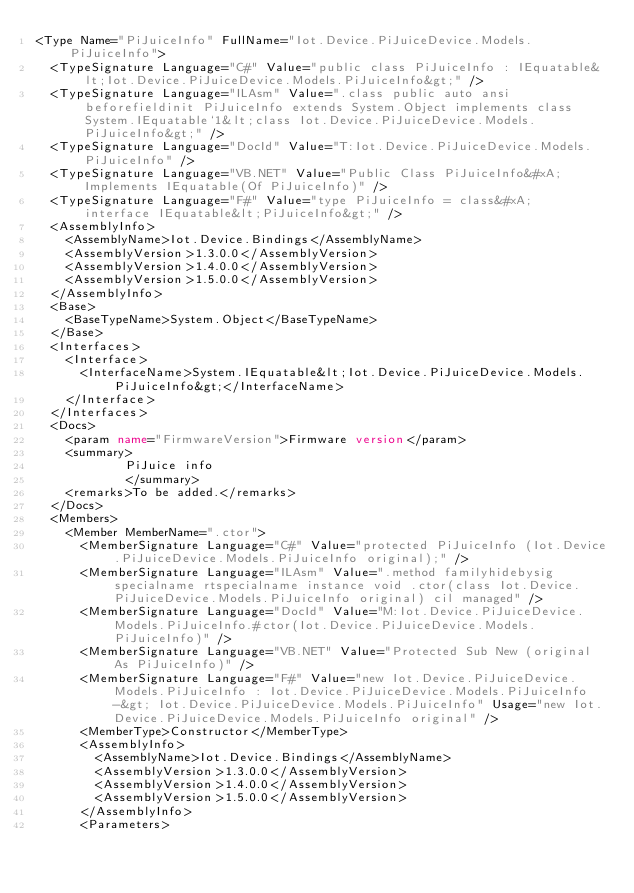Convert code to text. <code><loc_0><loc_0><loc_500><loc_500><_XML_><Type Name="PiJuiceInfo" FullName="Iot.Device.PiJuiceDevice.Models.PiJuiceInfo">
  <TypeSignature Language="C#" Value="public class PiJuiceInfo : IEquatable&lt;Iot.Device.PiJuiceDevice.Models.PiJuiceInfo&gt;" />
  <TypeSignature Language="ILAsm" Value=".class public auto ansi beforefieldinit PiJuiceInfo extends System.Object implements class System.IEquatable`1&lt;class Iot.Device.PiJuiceDevice.Models.PiJuiceInfo&gt;" />
  <TypeSignature Language="DocId" Value="T:Iot.Device.PiJuiceDevice.Models.PiJuiceInfo" />
  <TypeSignature Language="VB.NET" Value="Public Class PiJuiceInfo&#xA;Implements IEquatable(Of PiJuiceInfo)" />
  <TypeSignature Language="F#" Value="type PiJuiceInfo = class&#xA;    interface IEquatable&lt;PiJuiceInfo&gt;" />
  <AssemblyInfo>
    <AssemblyName>Iot.Device.Bindings</AssemblyName>
    <AssemblyVersion>1.3.0.0</AssemblyVersion>
    <AssemblyVersion>1.4.0.0</AssemblyVersion>
    <AssemblyVersion>1.5.0.0</AssemblyVersion>
  </AssemblyInfo>
  <Base>
    <BaseTypeName>System.Object</BaseTypeName>
  </Base>
  <Interfaces>
    <Interface>
      <InterfaceName>System.IEquatable&lt;Iot.Device.PiJuiceDevice.Models.PiJuiceInfo&gt;</InterfaceName>
    </Interface>
  </Interfaces>
  <Docs>
    <param name="FirmwareVersion">Firmware version</param>
    <summary>
            PiJuice info
            </summary>
    <remarks>To be added.</remarks>
  </Docs>
  <Members>
    <Member MemberName=".ctor">
      <MemberSignature Language="C#" Value="protected PiJuiceInfo (Iot.Device.PiJuiceDevice.Models.PiJuiceInfo original);" />
      <MemberSignature Language="ILAsm" Value=".method familyhidebysig specialname rtspecialname instance void .ctor(class Iot.Device.PiJuiceDevice.Models.PiJuiceInfo original) cil managed" />
      <MemberSignature Language="DocId" Value="M:Iot.Device.PiJuiceDevice.Models.PiJuiceInfo.#ctor(Iot.Device.PiJuiceDevice.Models.PiJuiceInfo)" />
      <MemberSignature Language="VB.NET" Value="Protected Sub New (original As PiJuiceInfo)" />
      <MemberSignature Language="F#" Value="new Iot.Device.PiJuiceDevice.Models.PiJuiceInfo : Iot.Device.PiJuiceDevice.Models.PiJuiceInfo -&gt; Iot.Device.PiJuiceDevice.Models.PiJuiceInfo" Usage="new Iot.Device.PiJuiceDevice.Models.PiJuiceInfo original" />
      <MemberType>Constructor</MemberType>
      <AssemblyInfo>
        <AssemblyName>Iot.Device.Bindings</AssemblyName>
        <AssemblyVersion>1.3.0.0</AssemblyVersion>
        <AssemblyVersion>1.4.0.0</AssemblyVersion>
        <AssemblyVersion>1.5.0.0</AssemblyVersion>
      </AssemblyInfo>
      <Parameters></code> 